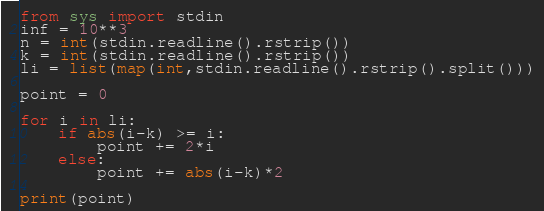Convert code to text. <code><loc_0><loc_0><loc_500><loc_500><_Python_>from sys import stdin
inf = 10**3
n = int(stdin.readline().rstrip())
k = int(stdin.readline().rstrip())
li = list(map(int,stdin.readline().rstrip().split()))

point = 0

for i in li:
    if abs(i-k) >= i:
        point += 2*i
    else:
        point += abs(i-k)*2

print(point)
</code> 